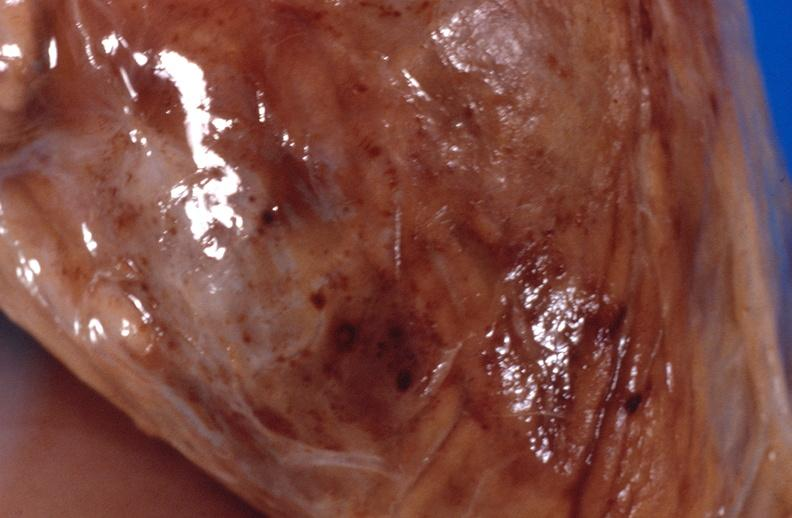what does this image show?
Answer the question using a single word or phrase. Panniculitis and fascitis 